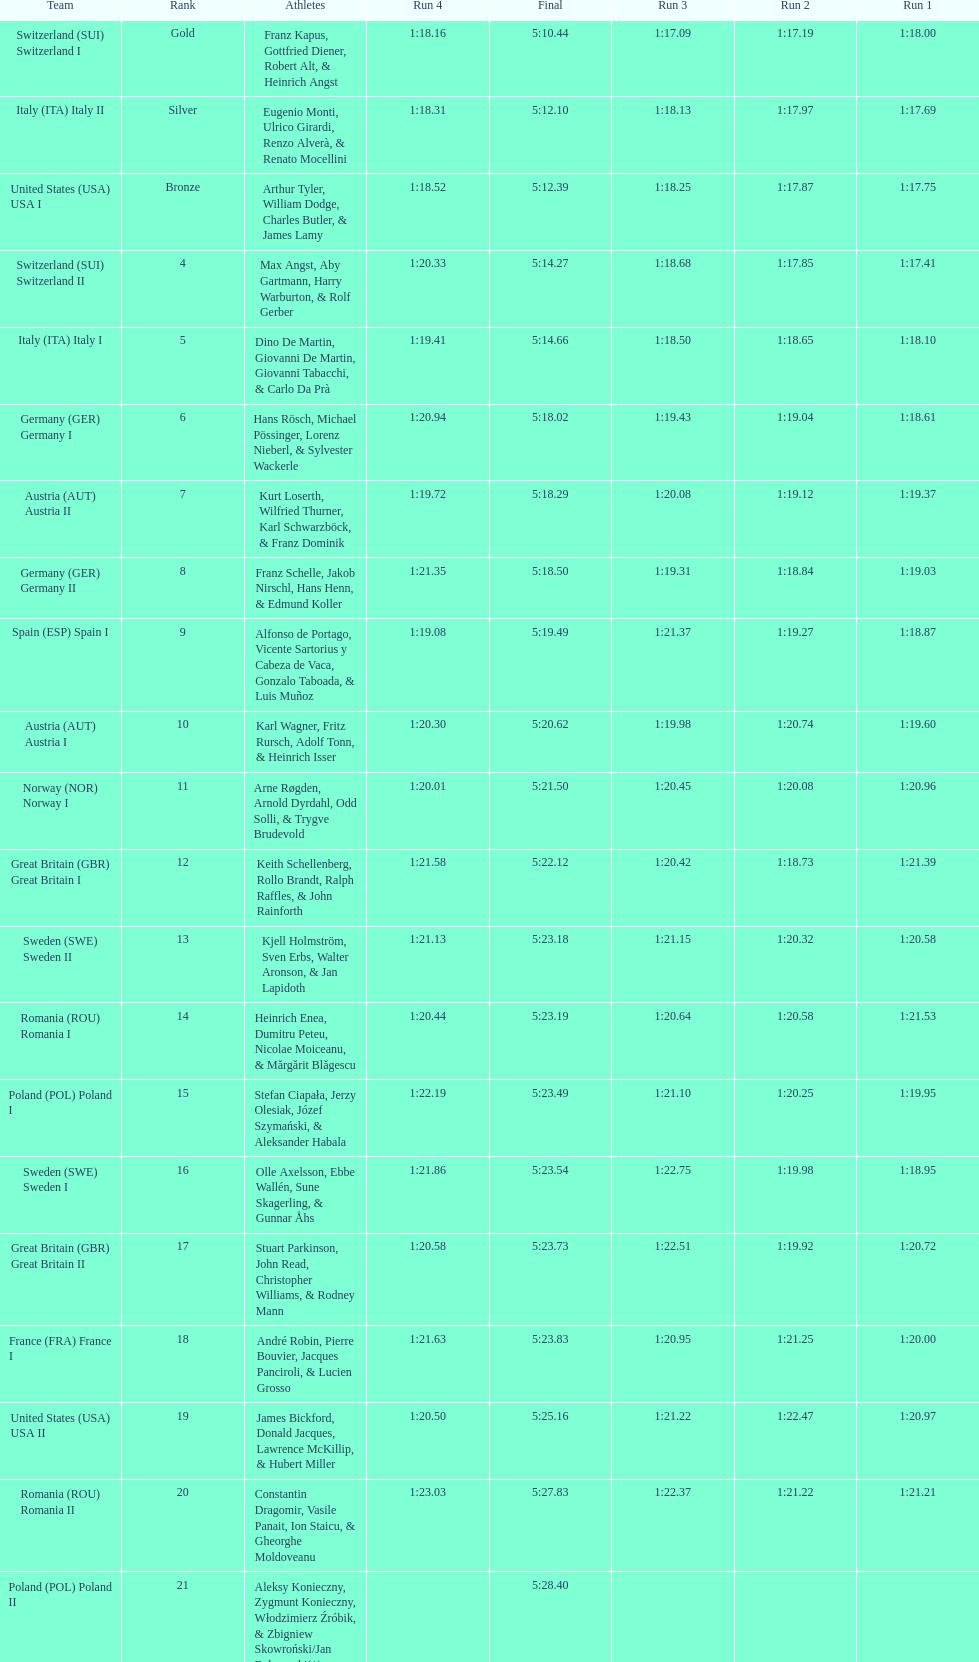What team came in second to last place? Romania. 